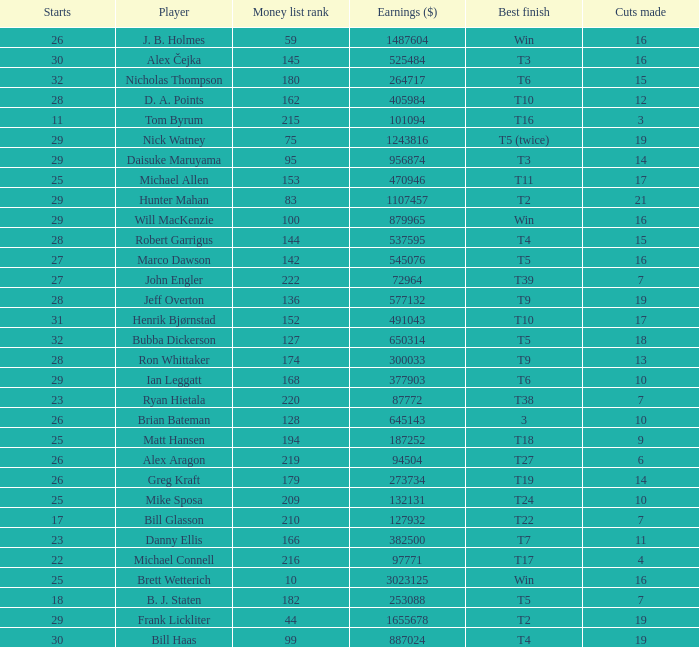What is the minimum number of cuts made for Hunter Mahan? 21.0. 